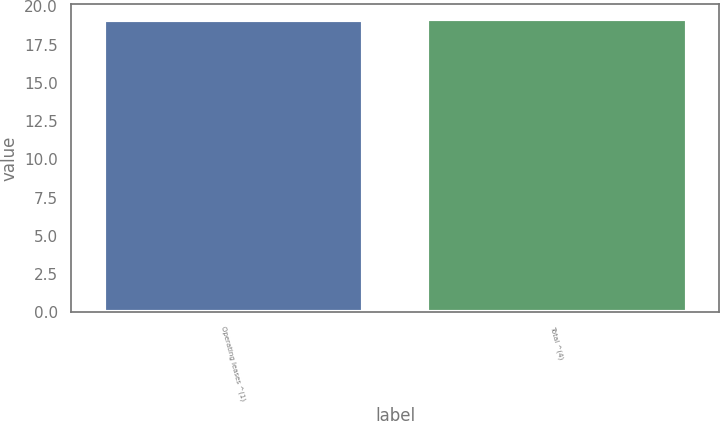<chart> <loc_0><loc_0><loc_500><loc_500><bar_chart><fcel>Operating leases ^(1)<fcel>Total ^(4)<nl><fcel>19.1<fcel>19.2<nl></chart> 